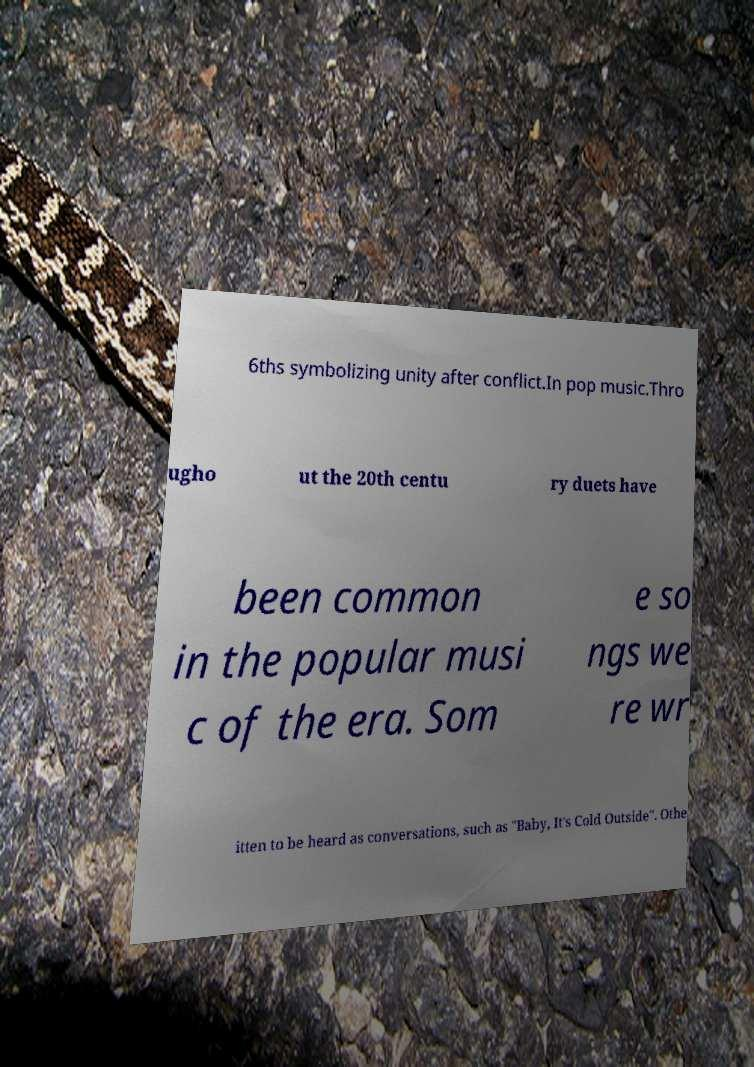Please identify and transcribe the text found in this image. 6ths symbolizing unity after conflict.In pop music.Thro ugho ut the 20th centu ry duets have been common in the popular musi c of the era. Som e so ngs we re wr itten to be heard as conversations, such as "Baby, It's Cold Outside". Othe 